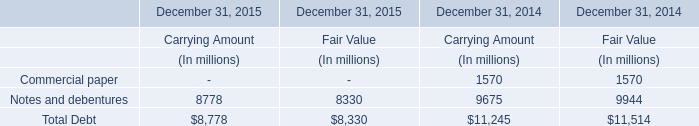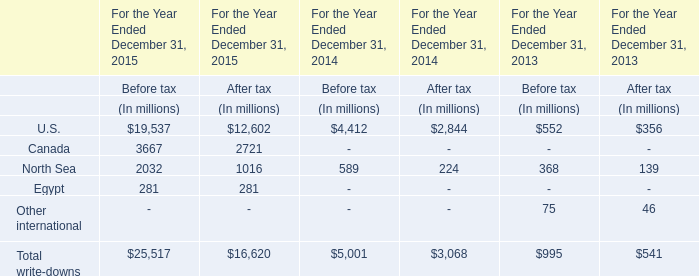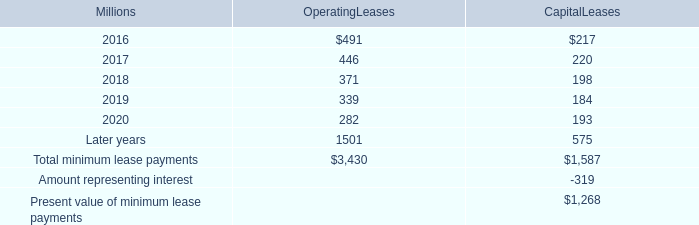what percentage of total minimum lease payments are operating leases leases? 
Computations: (3430 / (3430 + 1587))
Answer: 0.68368. 